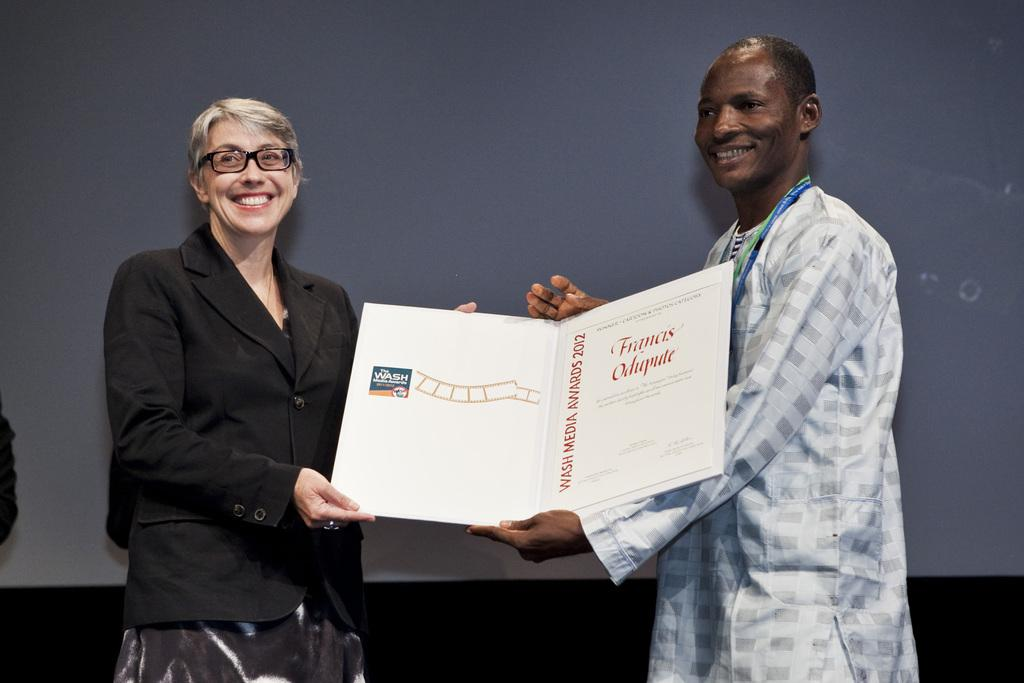How many people are in the image? There are two persons in the image. What are the persons doing in the image? The persons are standing and holding a card. What is the facial expression of the persons in the image? The persons are smiling. What can be seen in the background of the image? There is a wall in the background of the image. What is the income of the persons in the image? There is no information about the income of the persons in the image. Can you tell me how many beetles are present in the image? There are no beetles visible in the image. 